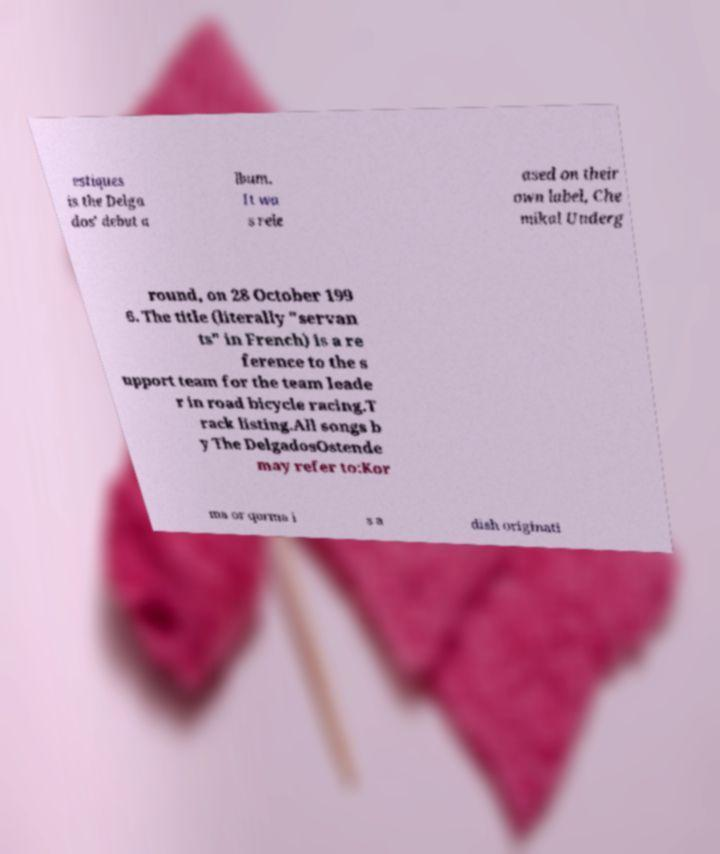Can you accurately transcribe the text from the provided image for me? estiques is the Delga dos' debut a lbum. It wa s rele ased on their own label, Che mikal Underg round, on 28 October 199 6. The title (literally "servan ts" in French) is a re ference to the s upport team for the team leade r in road bicycle racing.T rack listing.All songs b y The DelgadosOstende may refer to:Kor ma or qorma i s a dish originati 